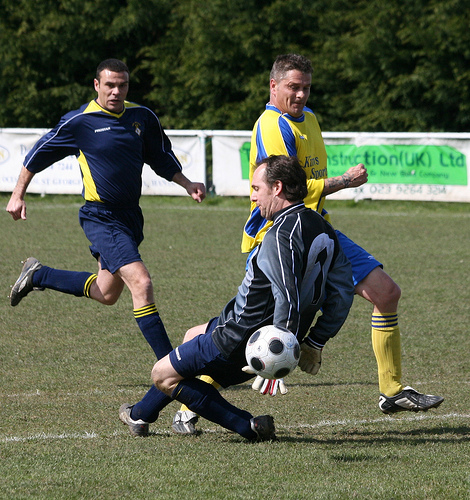<image>
Can you confirm if the ball is on the ground? No. The ball is not positioned on the ground. They may be near each other, but the ball is not supported by or resting on top of the ground. Is there a man behind the ball? Yes. From this viewpoint, the man is positioned behind the ball, with the ball partially or fully occluding the man. Is there a man to the right of the man? Yes. From this viewpoint, the man is positioned to the right side relative to the man. 